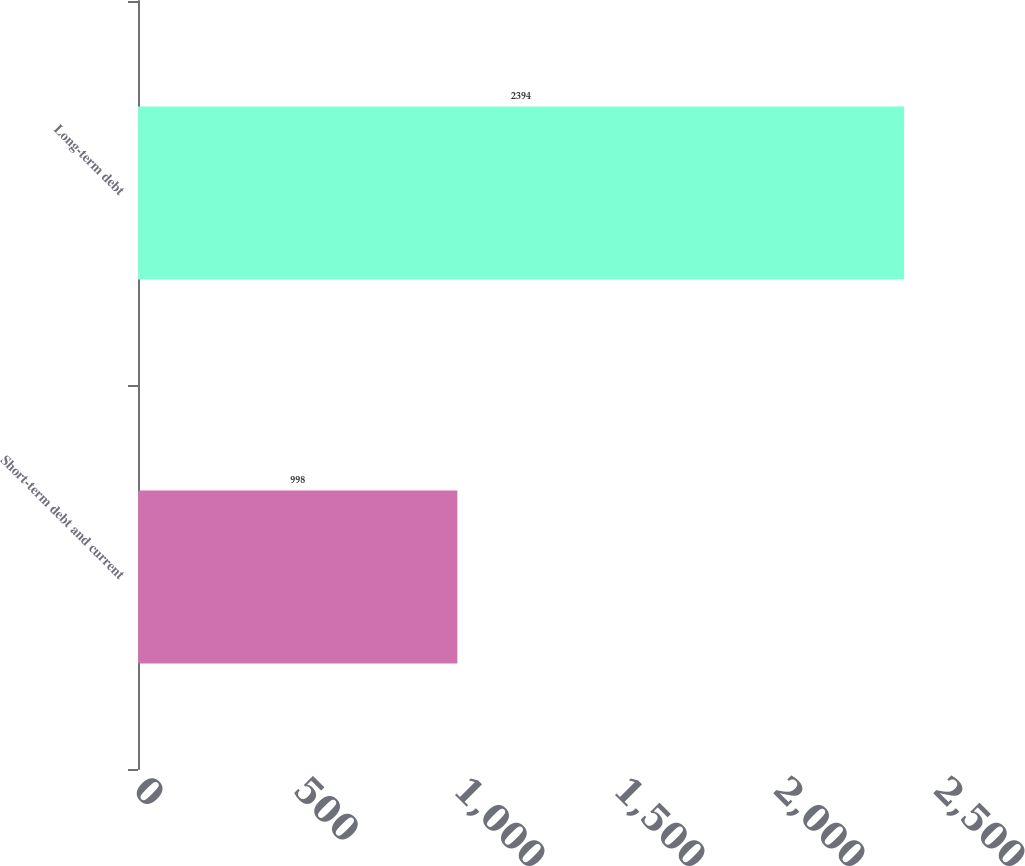Convert chart to OTSL. <chart><loc_0><loc_0><loc_500><loc_500><bar_chart><fcel>Short-term debt and current<fcel>Long-term debt<nl><fcel>998<fcel>2394<nl></chart> 